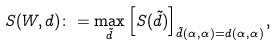Convert formula to latex. <formula><loc_0><loc_0><loc_500><loc_500>S ( W , d ) \colon = \max _ { \tilde { d } } \left [ S ( \tilde { d } ) \right ] _ { \tilde { d } ( \alpha , \alpha ) = d ( \alpha , \alpha ) } ,</formula> 